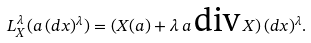<formula> <loc_0><loc_0><loc_500><loc_500>L _ { X } ^ { \lambda } ( a \, ( d x ) ^ { \lambda } ) = ( X ( { a } ) + \lambda \, a \, \text {div} \, X ) \, ( d x ) ^ { \lambda } .</formula> 